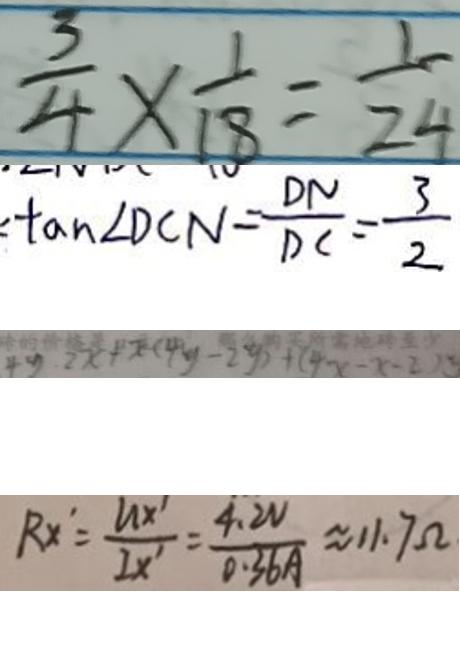<formula> <loc_0><loc_0><loc_500><loc_500>\frac { 3 } { 4 } \times \frac { 1 } { 1 8 } = \frac { 1 } { 2 4 } 
 \tan \angle D C N = \frac { D N } { D C } = \frac { 3 } { 2 } 
 4 y \cdot 2 x + x ( 4 y - 2 y ) + ( 4 x - x - 2 ) y 
 R x ^ { \prime } = \frac { U x ^ { \prime } } { I x ^ { \prime } } = \frac { 4 . 2 v } { 0 . 3 6 A } \approx 1 1 . 7 \Omega</formula> 